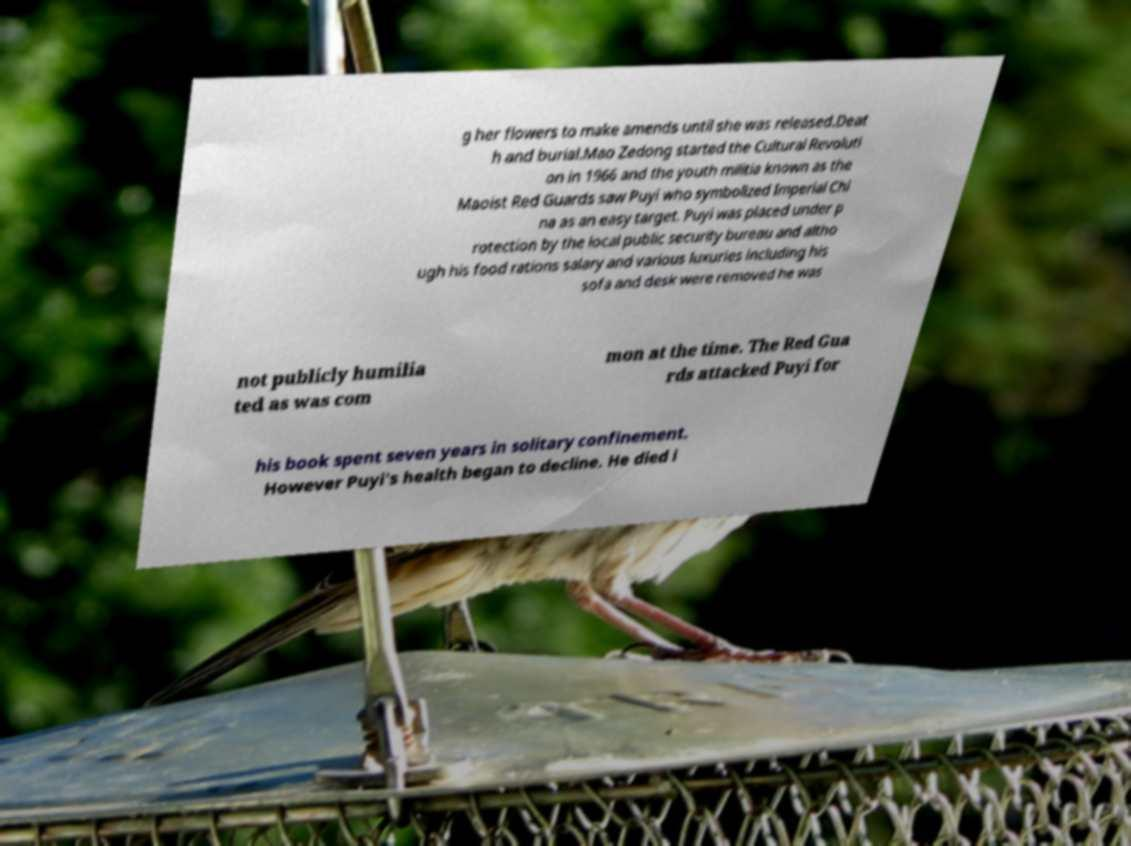For documentation purposes, I need the text within this image transcribed. Could you provide that? g her flowers to make amends until she was released.Deat h and burial.Mao Zedong started the Cultural Revoluti on in 1966 and the youth militia known as the Maoist Red Guards saw Puyi who symbolized Imperial Chi na as an easy target. Puyi was placed under p rotection by the local public security bureau and altho ugh his food rations salary and various luxuries including his sofa and desk were removed he was not publicly humilia ted as was com mon at the time. The Red Gua rds attacked Puyi for his book spent seven years in solitary confinement. However Puyi's health began to decline. He died i 